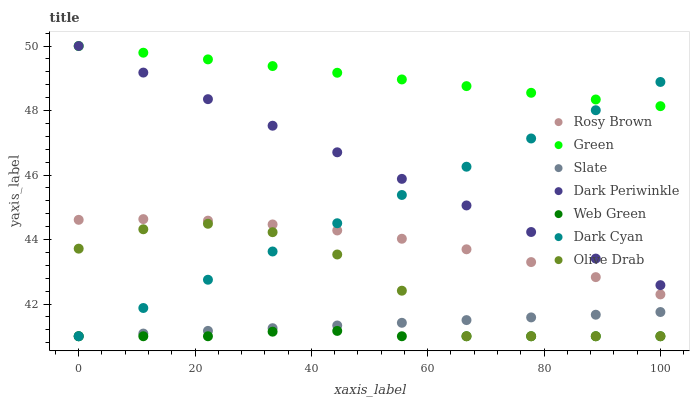Does Web Green have the minimum area under the curve?
Answer yes or no. Yes. Does Green have the maximum area under the curve?
Answer yes or no. Yes. Does Rosy Brown have the minimum area under the curve?
Answer yes or no. No. Does Rosy Brown have the maximum area under the curve?
Answer yes or no. No. Is Dark Periwinkle the smoothest?
Answer yes or no. Yes. Is Olive Drab the roughest?
Answer yes or no. Yes. Is Rosy Brown the smoothest?
Answer yes or no. No. Is Rosy Brown the roughest?
Answer yes or no. No. Does Slate have the lowest value?
Answer yes or no. Yes. Does Rosy Brown have the lowest value?
Answer yes or no. No. Does Dark Periwinkle have the highest value?
Answer yes or no. Yes. Does Rosy Brown have the highest value?
Answer yes or no. No. Is Rosy Brown less than Dark Periwinkle?
Answer yes or no. Yes. Is Rosy Brown greater than Slate?
Answer yes or no. Yes. Does Olive Drab intersect Dark Cyan?
Answer yes or no. Yes. Is Olive Drab less than Dark Cyan?
Answer yes or no. No. Is Olive Drab greater than Dark Cyan?
Answer yes or no. No. Does Rosy Brown intersect Dark Periwinkle?
Answer yes or no. No. 